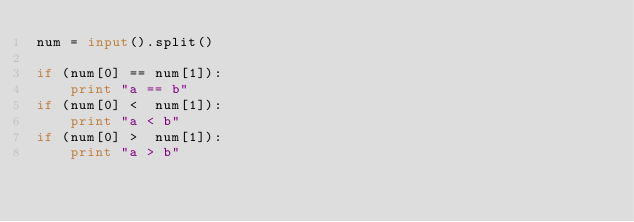Convert code to text. <code><loc_0><loc_0><loc_500><loc_500><_Python_>num = input().split()

if (num[0] == num[1]):
    print "a == b"
if (num[0] <  num[1]):
    print "a < b"
if (num[0] >  num[1]):
    print "a > b"</code> 